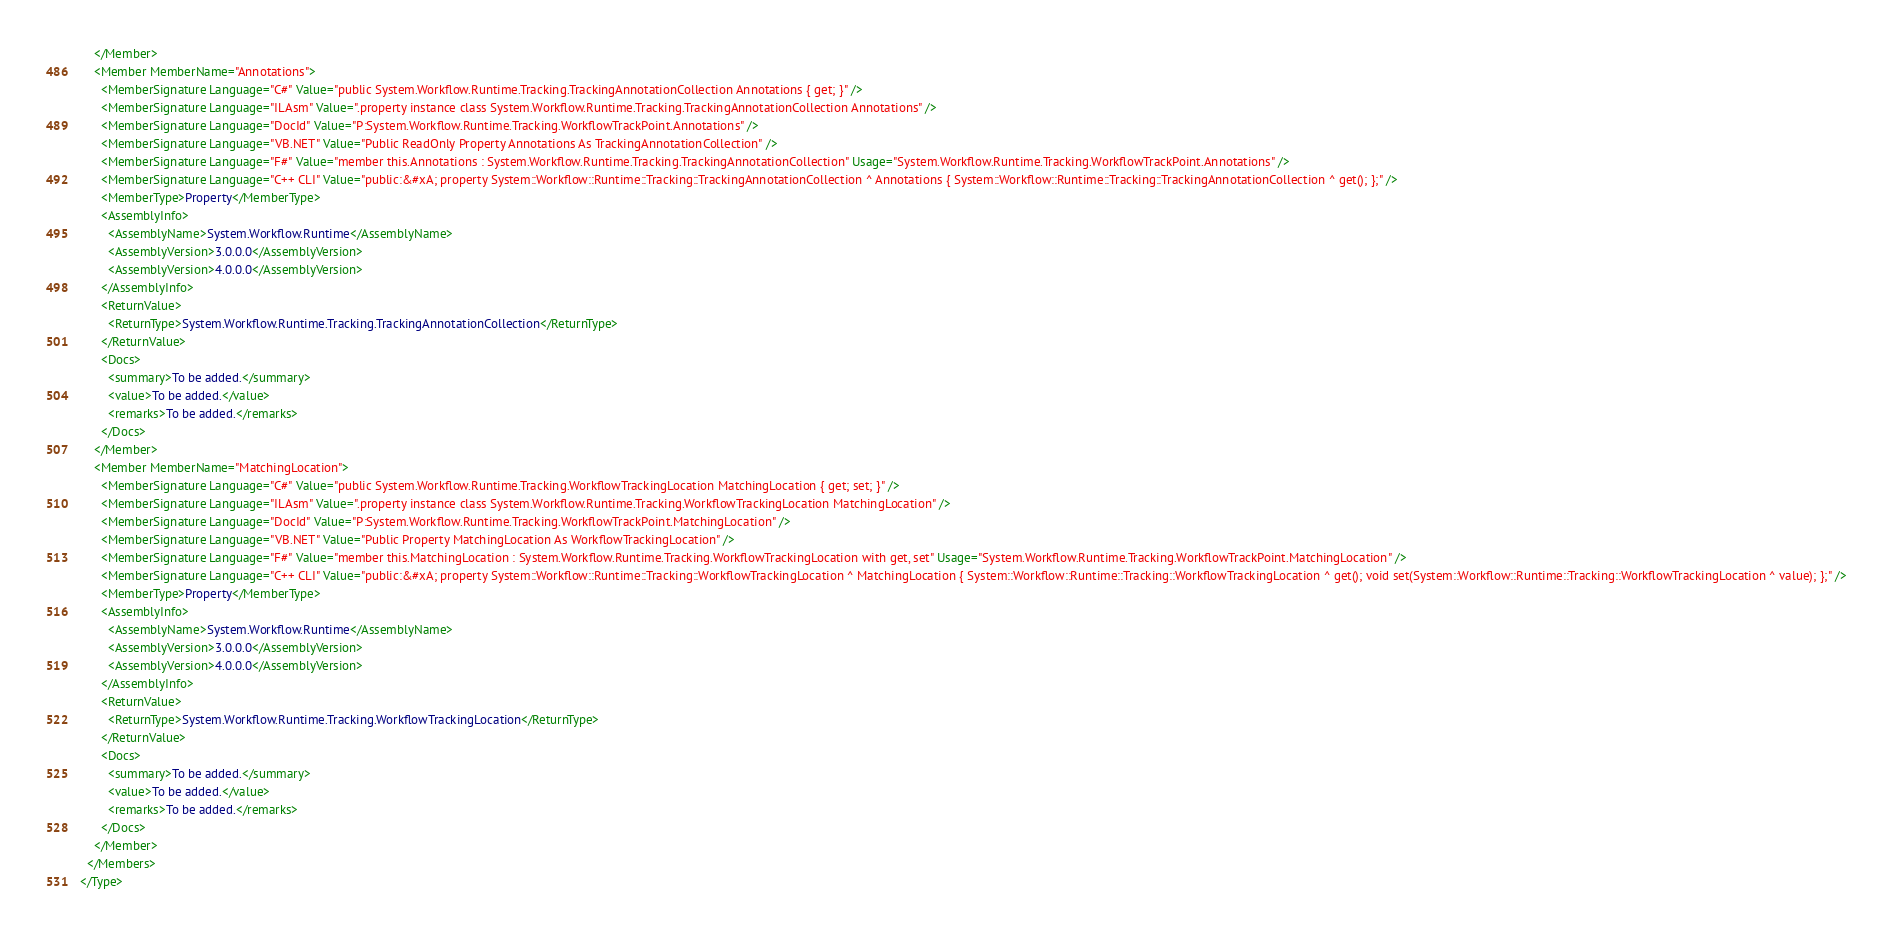Convert code to text. <code><loc_0><loc_0><loc_500><loc_500><_XML_>    </Member>
    <Member MemberName="Annotations">
      <MemberSignature Language="C#" Value="public System.Workflow.Runtime.Tracking.TrackingAnnotationCollection Annotations { get; }" />
      <MemberSignature Language="ILAsm" Value=".property instance class System.Workflow.Runtime.Tracking.TrackingAnnotationCollection Annotations" />
      <MemberSignature Language="DocId" Value="P:System.Workflow.Runtime.Tracking.WorkflowTrackPoint.Annotations" />
      <MemberSignature Language="VB.NET" Value="Public ReadOnly Property Annotations As TrackingAnnotationCollection" />
      <MemberSignature Language="F#" Value="member this.Annotations : System.Workflow.Runtime.Tracking.TrackingAnnotationCollection" Usage="System.Workflow.Runtime.Tracking.WorkflowTrackPoint.Annotations" />
      <MemberSignature Language="C++ CLI" Value="public:&#xA; property System::Workflow::Runtime::Tracking::TrackingAnnotationCollection ^ Annotations { System::Workflow::Runtime::Tracking::TrackingAnnotationCollection ^ get(); };" />
      <MemberType>Property</MemberType>
      <AssemblyInfo>
        <AssemblyName>System.Workflow.Runtime</AssemblyName>
        <AssemblyVersion>3.0.0.0</AssemblyVersion>
        <AssemblyVersion>4.0.0.0</AssemblyVersion>
      </AssemblyInfo>
      <ReturnValue>
        <ReturnType>System.Workflow.Runtime.Tracking.TrackingAnnotationCollection</ReturnType>
      </ReturnValue>
      <Docs>
        <summary>To be added.</summary>
        <value>To be added.</value>
        <remarks>To be added.</remarks>
      </Docs>
    </Member>
    <Member MemberName="MatchingLocation">
      <MemberSignature Language="C#" Value="public System.Workflow.Runtime.Tracking.WorkflowTrackingLocation MatchingLocation { get; set; }" />
      <MemberSignature Language="ILAsm" Value=".property instance class System.Workflow.Runtime.Tracking.WorkflowTrackingLocation MatchingLocation" />
      <MemberSignature Language="DocId" Value="P:System.Workflow.Runtime.Tracking.WorkflowTrackPoint.MatchingLocation" />
      <MemberSignature Language="VB.NET" Value="Public Property MatchingLocation As WorkflowTrackingLocation" />
      <MemberSignature Language="F#" Value="member this.MatchingLocation : System.Workflow.Runtime.Tracking.WorkflowTrackingLocation with get, set" Usage="System.Workflow.Runtime.Tracking.WorkflowTrackPoint.MatchingLocation" />
      <MemberSignature Language="C++ CLI" Value="public:&#xA; property System::Workflow::Runtime::Tracking::WorkflowTrackingLocation ^ MatchingLocation { System::Workflow::Runtime::Tracking::WorkflowTrackingLocation ^ get(); void set(System::Workflow::Runtime::Tracking::WorkflowTrackingLocation ^ value); };" />
      <MemberType>Property</MemberType>
      <AssemblyInfo>
        <AssemblyName>System.Workflow.Runtime</AssemblyName>
        <AssemblyVersion>3.0.0.0</AssemblyVersion>
        <AssemblyVersion>4.0.0.0</AssemblyVersion>
      </AssemblyInfo>
      <ReturnValue>
        <ReturnType>System.Workflow.Runtime.Tracking.WorkflowTrackingLocation</ReturnType>
      </ReturnValue>
      <Docs>
        <summary>To be added.</summary>
        <value>To be added.</value>
        <remarks>To be added.</remarks>
      </Docs>
    </Member>
  </Members>
</Type>
</code> 